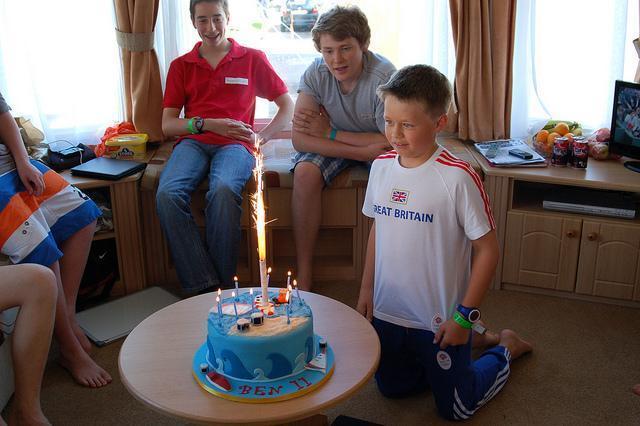How many people are there?
Give a very brief answer. 5. 